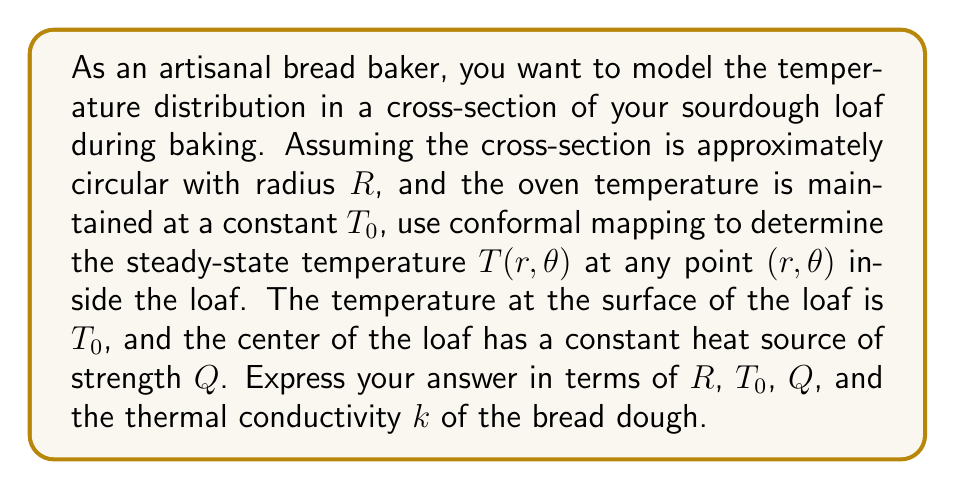Help me with this question. To solve this problem, we'll use conformal mapping and follow these steps:

1) First, we recognize that this problem is analogous to finding the electrostatic potential in a circular region with a line charge at the center. We can use the same mathematical approach.

2) The general solution for the temperature in polar coordinates, satisfying Laplace's equation, is:

   $$T(r,\theta) = A_0 + B_0 \ln r + \sum_{n=1}^{\infty} (A_n r^n + B_n r^{-n}) (C_n \cos n\theta + D_n \sin n\theta)$$

3) Due to the radial symmetry of our problem, the solution will not depend on $\theta$, simplifying our equation to:

   $$T(r) = A_0 + B_0 \ln r$$

4) We have two boundary conditions:
   a) At $r = R$, $T(R) = T_0$
   b) At $r = 0$, there's a heat source $Q$, which means $-2\pi k r \frac{dT}{dr} = Q$ as $r \to 0$

5) Applying the first boundary condition:

   $$T_0 = A_0 + B_0 \ln R$$

6) For the second condition, we differentiate $T(r)$:

   $$\frac{dT}{dr} = \frac{B_0}{r}$$

   Applying the heat source condition:

   $$-2\pi k r \cdot \frac{B_0}{r} = Q$$
   $$B_0 = -\frac{Q}{2\pi k}$$

7) Now we can solve for $A_0$ using the equation from step 5:

   $$A_0 = T_0 + \frac{Q}{2\pi k} \ln R$$

8) Substituting these values back into our general solution:

   $$T(r) = T_0 + \frac{Q}{2\pi k} \ln R - \frac{Q}{2\pi k} \ln r$$

9) This can be rewritten as:

   $$T(r) = T_0 + \frac{Q}{2\pi k} \ln (\frac{R}{r})$$

This is our final expression for the temperature distribution in the loaf.
Answer: $$T(r) = T_0 + \frac{Q}{2\pi k} \ln (\frac{R}{r})$$ 